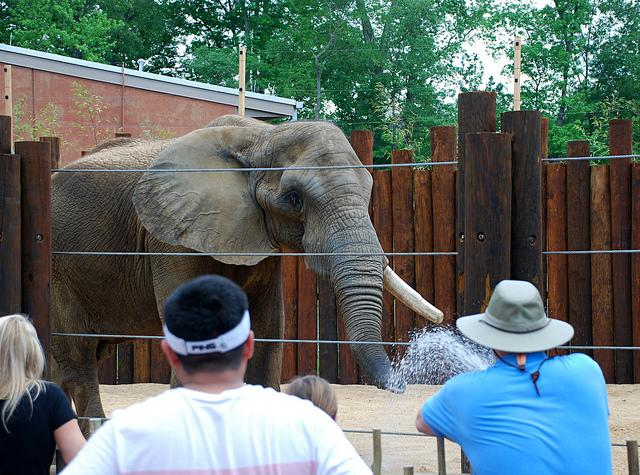What are people watching the elephant likely to use to shoot it?

Choices:
A) camera
B) gun
C) bow/ arrows
D) darts camera 